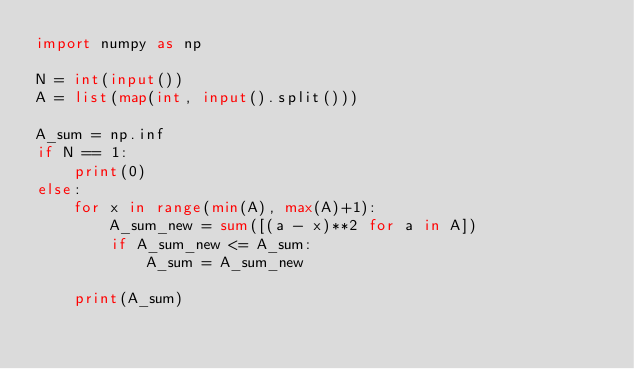<code> <loc_0><loc_0><loc_500><loc_500><_Python_>import numpy as np

N = int(input())
A = list(map(int, input().split()))

A_sum = np.inf
if N == 1:
    print(0)
else:
    for x in range(min(A), max(A)+1):
        A_sum_new = sum([(a - x)**2 for a in A])
        if A_sum_new <= A_sum:
            A_sum = A_sum_new

    print(A_sum)
</code> 